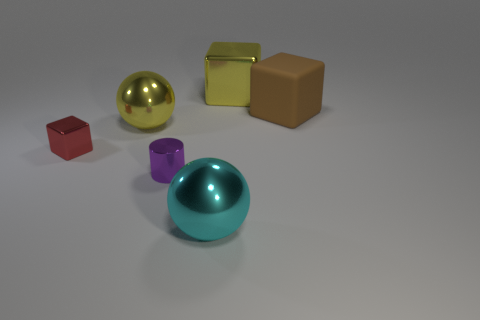Add 3 brown rubber cubes. How many objects exist? 9 Subtract all balls. How many objects are left? 4 Add 5 yellow things. How many yellow things are left? 7 Add 6 brown metallic cylinders. How many brown metallic cylinders exist? 6 Subtract 0 purple blocks. How many objects are left? 6 Subtract all tiny metallic cylinders. Subtract all gray spheres. How many objects are left? 5 